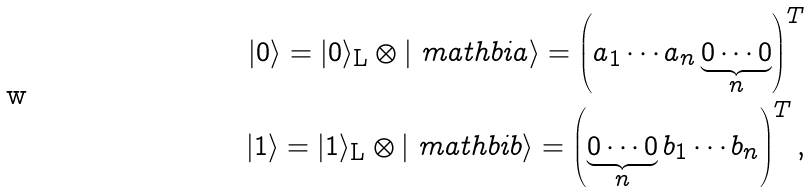<formula> <loc_0><loc_0><loc_500><loc_500>| 0 \rangle = | 0 \rangle _ { \text {L} } \otimes | \ m a t h b i { a } \rangle = \left ( a _ { 1 } \cdots a _ { n } \underbrace { 0 \cdots 0 } _ { n } \right ) ^ { T } \\ | 1 \rangle = | 1 \rangle _ { \text {L} } \otimes | \ m a t h b i { b } \rangle = \left ( \underbrace { 0 \cdots 0 } _ { n } b _ { 1 } \cdots b _ { n } \right ) ^ { T } ,</formula> 